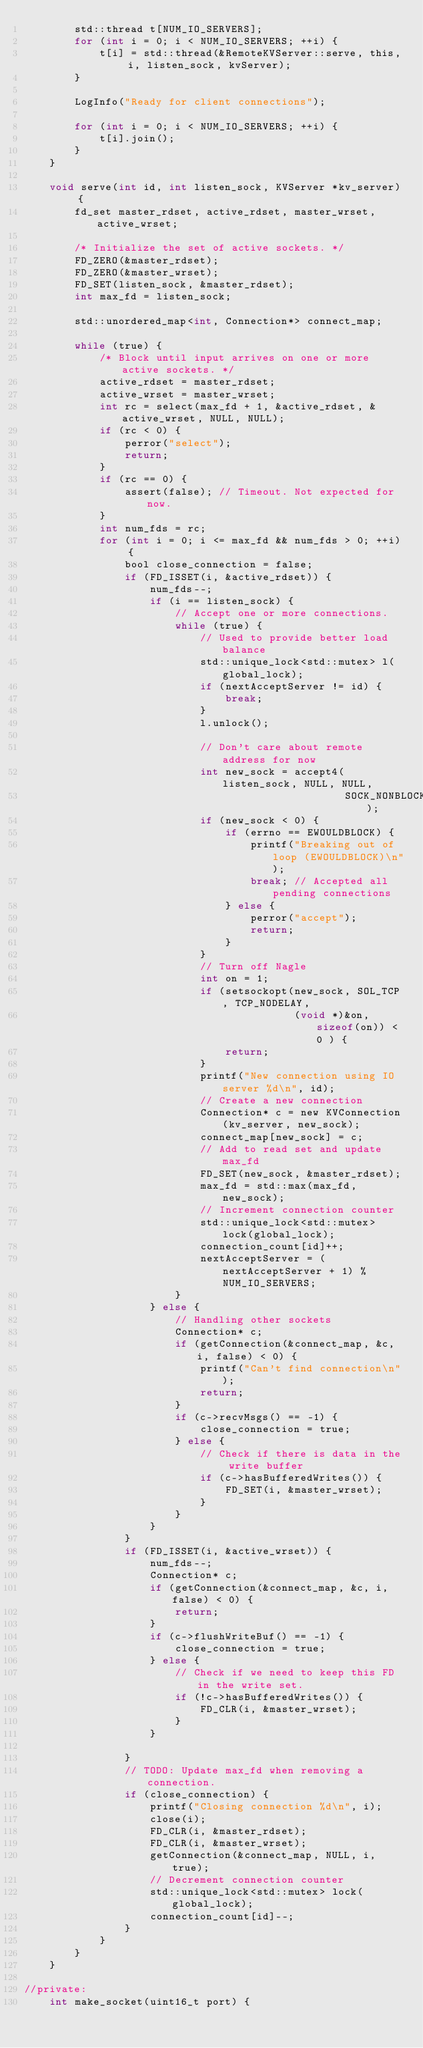Convert code to text. <code><loc_0><loc_0><loc_500><loc_500><_C_>        std::thread t[NUM_IO_SERVERS];
        for (int i = 0; i < NUM_IO_SERVERS; ++i) {
            t[i] = std::thread(&RemoteKVServer::serve, this, i, listen_sock, kvServer);
        }

        LogInfo("Ready for client connections");

        for (int i = 0; i < NUM_IO_SERVERS; ++i) {
            t[i].join();
        }
    }

    void serve(int id, int listen_sock, KVServer *kv_server) {
        fd_set master_rdset, active_rdset, master_wrset, active_wrset;

        /* Initialize the set of active sockets. */
        FD_ZERO(&master_rdset);
        FD_ZERO(&master_wrset);
        FD_SET(listen_sock, &master_rdset);
        int max_fd = listen_sock;

        std::unordered_map<int, Connection*> connect_map;

        while (true) {
            /* Block until input arrives on one or more active sockets. */
            active_rdset = master_rdset;
            active_wrset = master_wrset;
            int rc = select(max_fd + 1, &active_rdset, &active_wrset, NULL, NULL);
            if (rc < 0) {
                perror("select");
                return;
            }
            if (rc == 0) {
                assert(false); // Timeout. Not expected for now.
            }
            int num_fds = rc;
            for (int i = 0; i <= max_fd && num_fds > 0; ++i) {
                bool close_connection = false;
                if (FD_ISSET(i, &active_rdset)) {
                    num_fds--;
                    if (i == listen_sock) {
                        // Accept one or more connections.
                        while (true) {
                            // Used to provide better load balance
                            std::unique_lock<std::mutex> l(global_lock);
                            if (nextAcceptServer != id) {
                                break;
                            }
                            l.unlock();

                            // Don't care about remote address for now
                            int new_sock = accept4(listen_sock, NULL, NULL,
                                                   SOCK_NONBLOCK);
                            if (new_sock < 0) {
                                if (errno == EWOULDBLOCK) {
                                    printf("Breaking out of loop (EWOULDBLOCK)\n");
                                    break; // Accepted all pending connections
                                } else {
                                    perror("accept");
                                    return;
                                }
                            }
                            // Turn off Nagle
                            int on = 1;
                            if (setsockopt(new_sock, SOL_TCP, TCP_NODELAY,
                                           (void *)&on, sizeof(on)) < 0 ) {
                                return;
                            }
                            printf("New connection using IO server %d\n", id);
                            // Create a new connection
                            Connection* c = new KVConnection(kv_server, new_sock);
                            connect_map[new_sock] = c;
                            // Add to read set and update max_fd
                            FD_SET(new_sock, &master_rdset);
                            max_fd = std::max(max_fd, new_sock);
                            // Increment connection counter
                            std::unique_lock<std::mutex> lock(global_lock);
                            connection_count[id]++;
                            nextAcceptServer = (nextAcceptServer + 1) % NUM_IO_SERVERS;
                        }
                    } else {
                        // Handling other sockets
                        Connection* c;
                        if (getConnection(&connect_map, &c, i, false) < 0) {
                            printf("Can't find connection\n");
                            return;
                        }
                        if (c->recvMsgs() == -1) {
                            close_connection = true;
                        } else {
                            // Check if there is data in the write buffer
                            if (c->hasBufferedWrites()) {
                                FD_SET(i, &master_wrset);
                            }
                        }
                    }
                }
                if (FD_ISSET(i, &active_wrset)) {
                    num_fds--;
                    Connection* c;
                    if (getConnection(&connect_map, &c, i, false) < 0) {
                        return;
                    }
                    if (c->flushWriteBuf() == -1) {
                        close_connection = true;
                    } else {
                        // Check if we need to keep this FD in the write set.
                        if (!c->hasBufferedWrites()) {
                            FD_CLR(i, &master_wrset);
                        }
                    }

                }
                // TODO: Update max_fd when removing a connection.
                if (close_connection) {
                    printf("Closing connection %d\n", i);
                    close(i);
                    FD_CLR(i, &master_rdset);
                    FD_CLR(i, &master_wrset);
                    getConnection(&connect_map, NULL, i, true);
                    // Decrement connection counter
                    std::unique_lock<std::mutex> lock(global_lock);
                    connection_count[id]--;
                }
            }
        }
    }

//private:
    int make_socket(uint16_t port) {</code> 